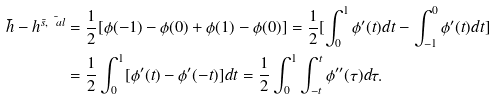<formula> <loc_0><loc_0><loc_500><loc_500>\bar { h } - h ^ { \bar { s } , \bar { \ a l } } & = \frac { 1 } { 2 } [ \phi ( - 1 ) - \phi ( 0 ) + \phi ( 1 ) - \phi ( 0 ) ] = \frac { 1 } { 2 } [ \int _ { 0 } ^ { 1 } \phi ^ { \prime } ( t ) d t - \int _ { - 1 } ^ { 0 } \phi ^ { \prime } ( t ) d t ] \\ & = \frac { 1 } { 2 } \int _ { 0 } ^ { 1 } [ \phi ^ { \prime } ( t ) - \phi ^ { \prime } ( - t ) ] d t = \frac { 1 } { 2 } \int _ { 0 } ^ { 1 } \int _ { - t } ^ { t } \phi ^ { \prime \prime } ( \tau ) d \tau .</formula> 